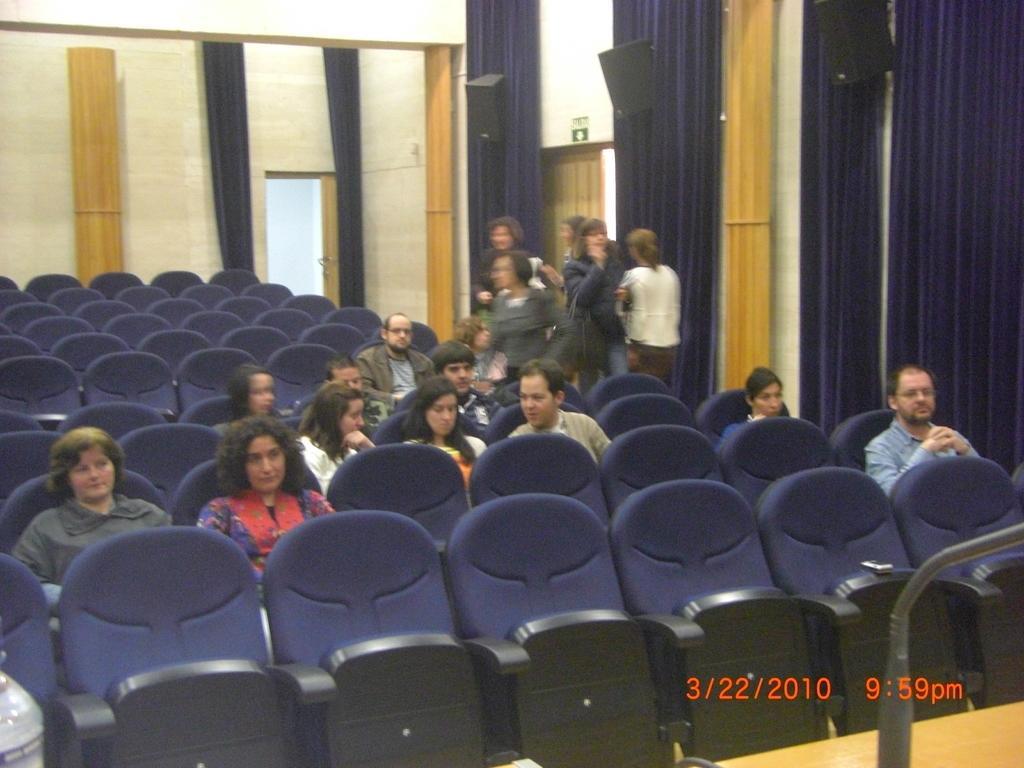Could you give a brief overview of what you see in this image? In this image we can see some people sitting on the chairs. We can also see some empty chairs. On the backside there are some people standing. We can also see some speakers to the wall, doors and curtains. 